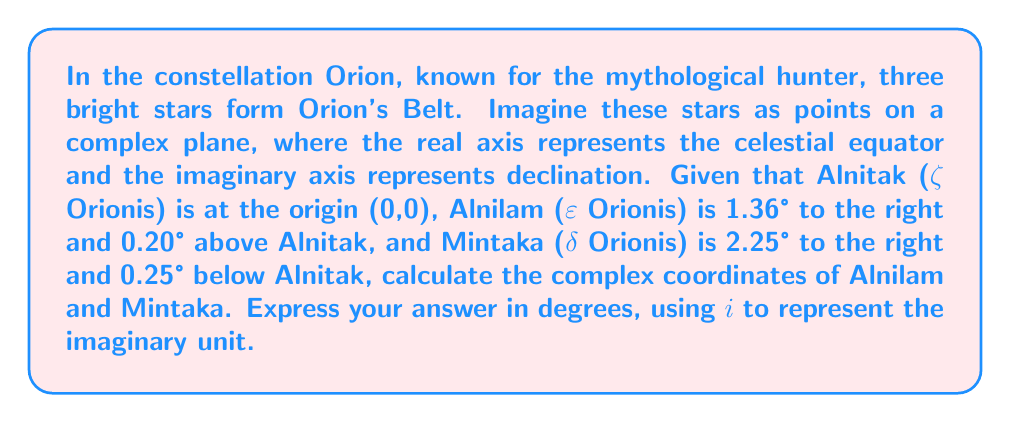Solve this math problem. To solve this problem, we need to convert the given information into complex numbers. The real part represents the horizontal displacement (right is positive), and the imaginary part represents the vertical displacement (up is positive).

For Alnilam (ε Orionis):
- Horizontal displacement: 1.36° to the right
- Vertical displacement: 0.20° above

We can represent this as a complex number:
$$ z_{\text{Alnilam}} = 1.36 + 0.20i $$

For Mintaka (δ Orionis):
- Horizontal displacement: 2.25° to the right
- Vertical displacement: 0.25° below

We can represent this as a complex number:
$$ z_{\text{Mintaka}} = 2.25 - 0.25i $$

Note that the vertical displacement is negative for Mintaka because it's below the reference point.

These complex numbers represent the positions of the stars relative to Alnitak in the complex plane, where each unit represents one degree of arc in the sky.
Answer: Alnilam: $1.36 + 0.20i$ degrees
Mintaka: $2.25 - 0.25i$ degrees 